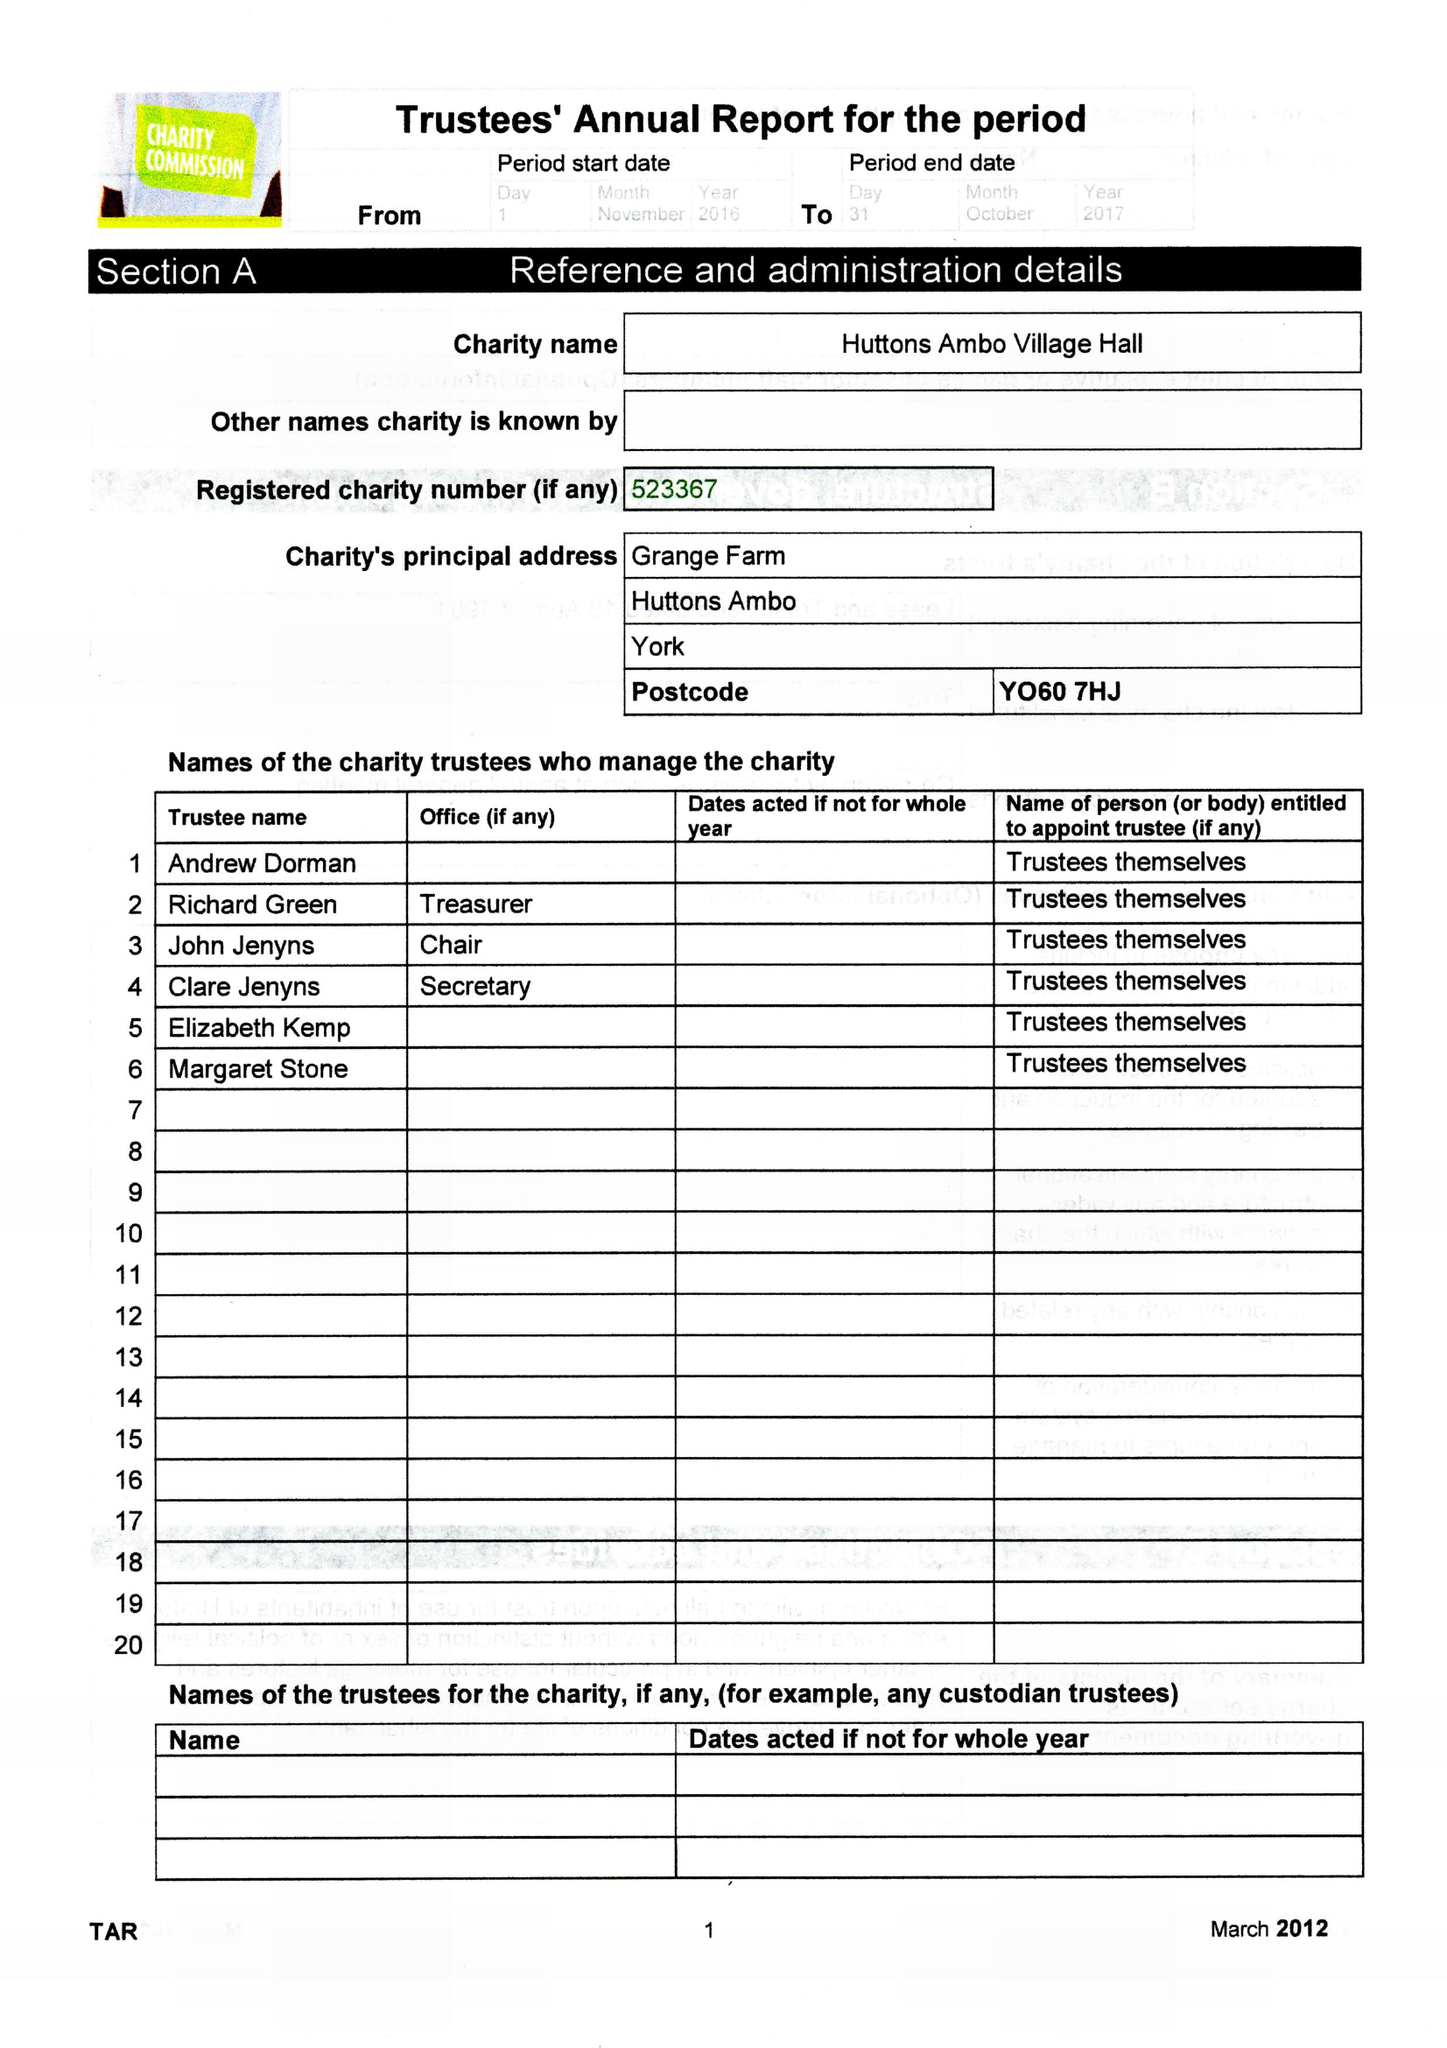What is the value for the address__street_line?
Answer the question using a single word or phrase. GRANGE FARM 